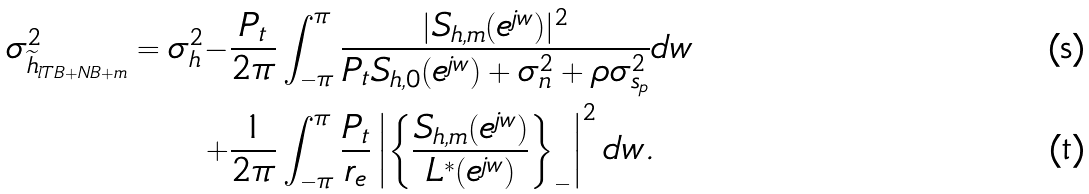<formula> <loc_0><loc_0><loc_500><loc_500>\sigma _ { \widetilde { h } _ { l T B + N B + m } } ^ { 2 } = \sigma _ { h } ^ { 2 } - & \frac { P _ { t } } { 2 \pi } \int _ { - \pi } ^ { \pi } \frac { | S _ { h , m } ( e ^ { j w } ) | ^ { 2 } } { P _ { t } S _ { h , 0 } ( e ^ { j w } ) + \sigma _ { n } ^ { 2 } + \rho \sigma _ { s _ { p } } ^ { 2 } } d w \\ + & \frac { 1 } { 2 \pi } \int _ { - \pi } ^ { \pi } \frac { P _ { t } } { r _ { e } } \left | \left \{ \frac { S _ { h , m } ( e ^ { j w } ) } { L ^ { * } ( e ^ { j w } ) } \right \} _ { - } \right | ^ { 2 } d w .</formula> 